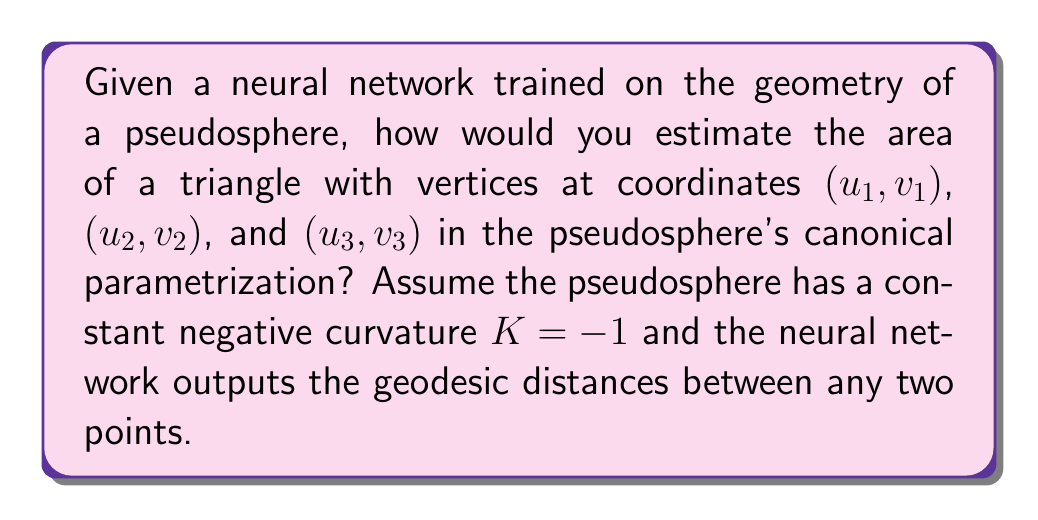Show me your answer to this math problem. To estimate the area of a triangle on a pseudosphere using neural networks, we can follow these steps:

1. Use the trained neural network to obtain the geodesic distances between the three vertices of the triangle. Let's call these distances $a$, $b$, and $c$.

2. Recall that for a triangle on a surface with constant negative curvature $K = -1$, the area $A$ is given by the formula:

   $$A = \pi - (\alpha + \beta + \gamma)$$

   where $\alpha$, $\beta$, and $\gamma$ are the interior angles of the triangle.

3. To find the interior angles, we can use the hyperbolic law of cosines:

   $$\cosh(c) = \cosh(a)\cosh(b) - \sinh(a)\sinh(b)\cos(\gamma)$$

   Similar equations hold for angles $\alpha$ and $\beta$.

4. Rearranging the hyperbolic law of cosines, we get:

   $$\gamma = \arccos\left(\frac{\cosh(c) - \cosh(a)\cosh(b)}{\sinh(a)\sinh(b)}\right)$$

5. Calculate $\alpha$, $\beta$, and $\gamma$ using this formula and the distances obtained from the neural network.

6. Finally, compute the area using the formula from step 2.

7. Implement this calculation in a blockchain smart contract that interfaces with the neural network to obtain the geodesic distances.
Answer: $A = \pi - \sum_{i=1}^3 \arccos\left(\frac{\cosh(c_i) - \cosh(a_i)\cosh(b_i)}{\sinh(a_i)\sinh(b_i)}\right)$ 